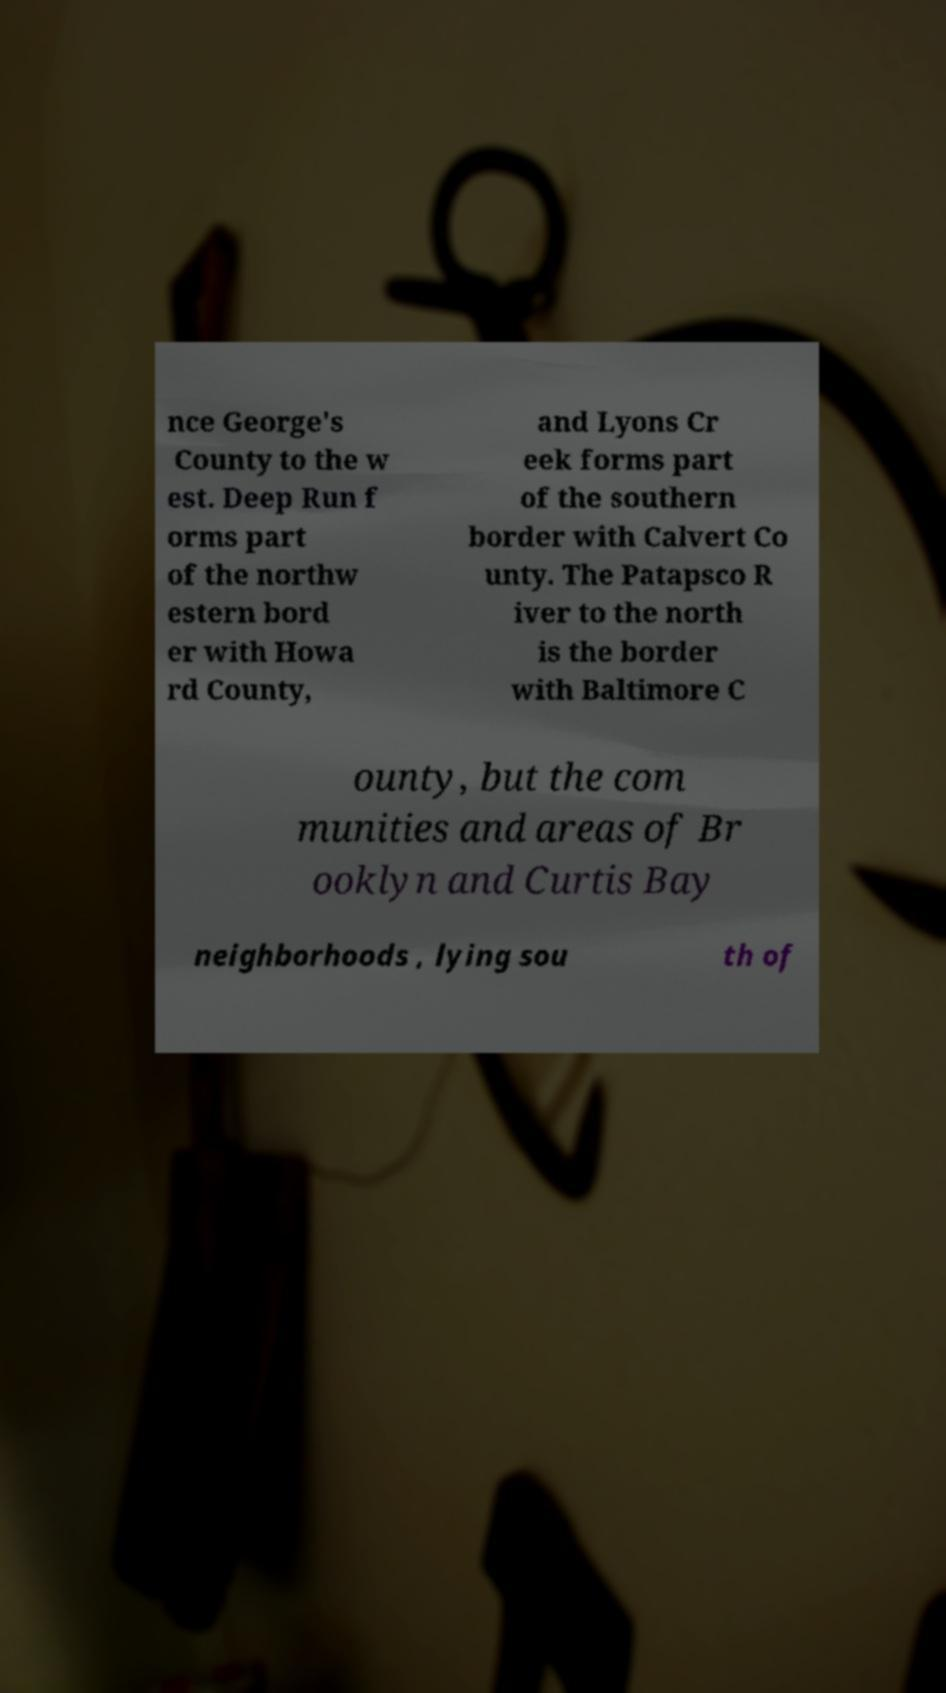I need the written content from this picture converted into text. Can you do that? nce George's County to the w est. Deep Run f orms part of the northw estern bord er with Howa rd County, and Lyons Cr eek forms part of the southern border with Calvert Co unty. The Patapsco R iver to the north is the border with Baltimore C ounty, but the com munities and areas of Br ooklyn and Curtis Bay neighborhoods , lying sou th of 